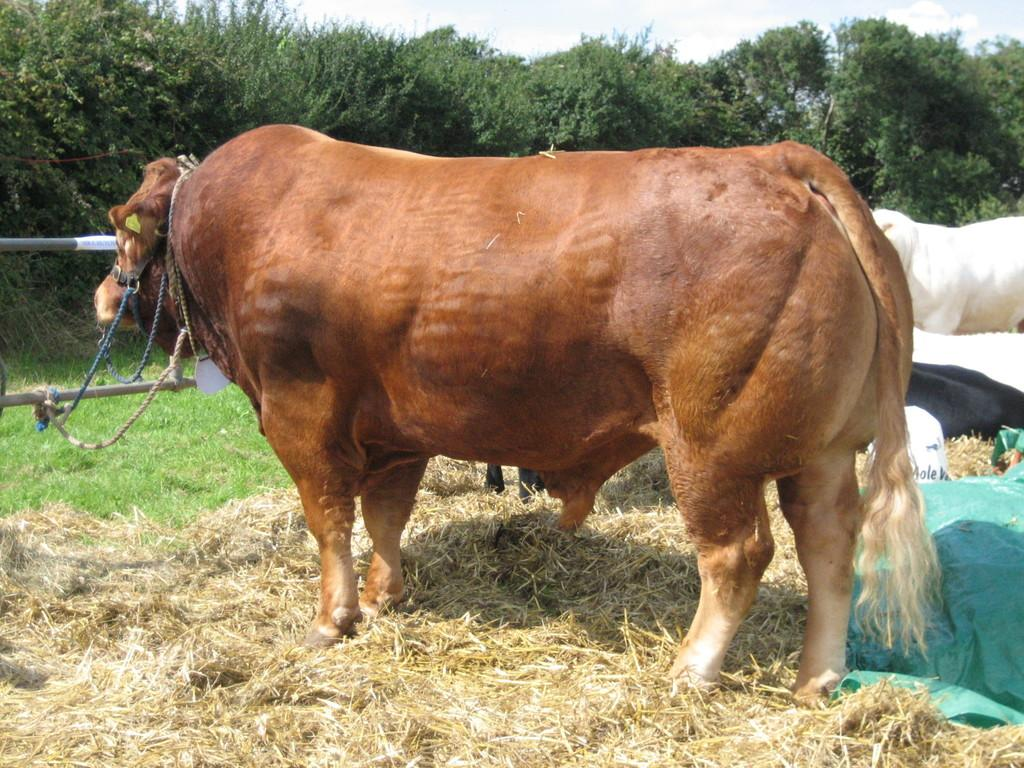What types of living organisms can be seen in the image? There are animals in the image. What is on the ground in the image? Dried grass is present on the ground. What can be seen in the background of the image? There are trees and the sky visible in the background of the image. What type of berry is being used to express a belief in the image? There is no berry or expression of belief present in the image. 